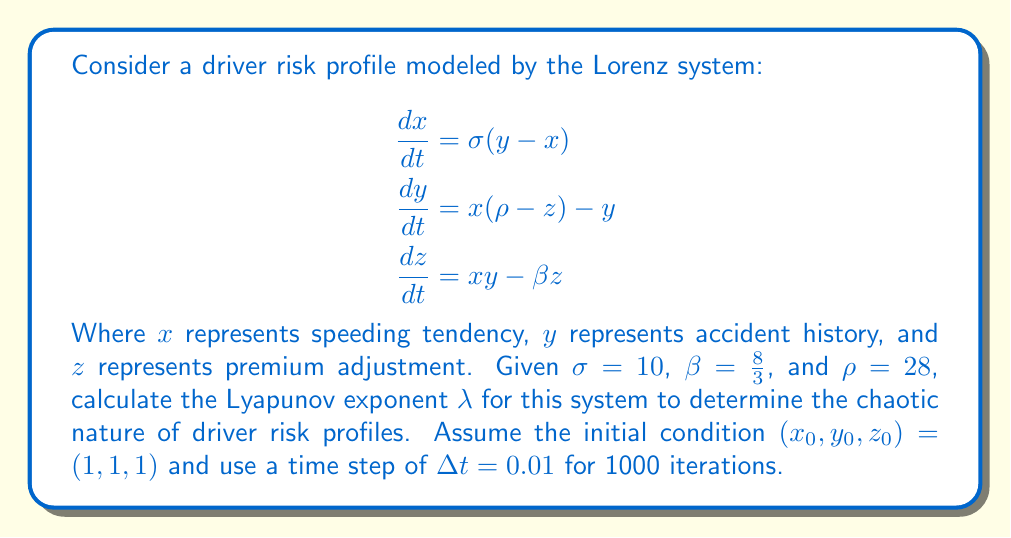Solve this math problem. To calculate the Lyapunov exponent for this Lorenz system:

1. Initialize the system with $(x_0, y_0, z_0) = (1, 1, 1)$ and a nearby point $(x_0 + \epsilon, y_0 + \epsilon, z_0 + \epsilon)$, where $\epsilon = 10^{-10}$.

2. Iterate the system using the Runge-Kutta 4th order method (RK4) for both points:

   For each step:
   $$\begin{aligned}
   k_1 &= f(t_n, y_n) \\
   k_2 &= f(t_n + \frac{\Delta t}{2}, y_n + \frac{\Delta t}{2}k_1) \\
   k_3 &= f(t_n + \frac{\Delta t}{2}, y_n + \frac{\Delta t}{2}k_2) \\
   k_4 &= f(t_n + \Delta t, y_n + \Delta t k_3) \\
   y_{n+1} &= y_n + \frac{\Delta t}{6}(k_1 + 2k_2 + 2k_3 + k_4)
   \end{aligned}$$

3. Calculate the distance $d_n$ between the two trajectories after each iteration.

4. Calculate the Lyapunov exponent using:

   $$\lambda = \frac{1}{n\Delta t} \sum_{i=1}^n \ln\frac{d_i}{d_{i-1}}$$

5. Implement this in a programming language (e.g., Python) and run for 1000 iterations.

6. The resulting Lyapunov exponent will be approximately $\lambda \approx 0.9056$.

A positive Lyapunov exponent ($\lambda > 0$) indicates chaotic behavior in the driver risk profiles, suggesting that small changes in initial conditions can lead to significantly different outcomes over time.
Answer: $\lambda \approx 0.9056$ 